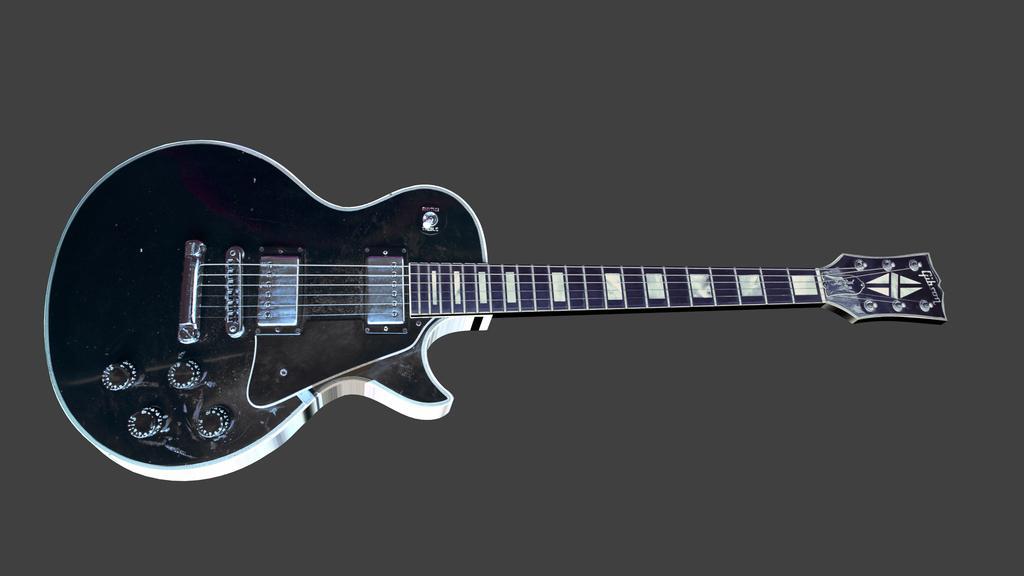In one or two sentences, can you explain what this image depicts? In this picture, we see a guitar. It is in black and white color. In the background, it is grey in color. This might be an edited image. 